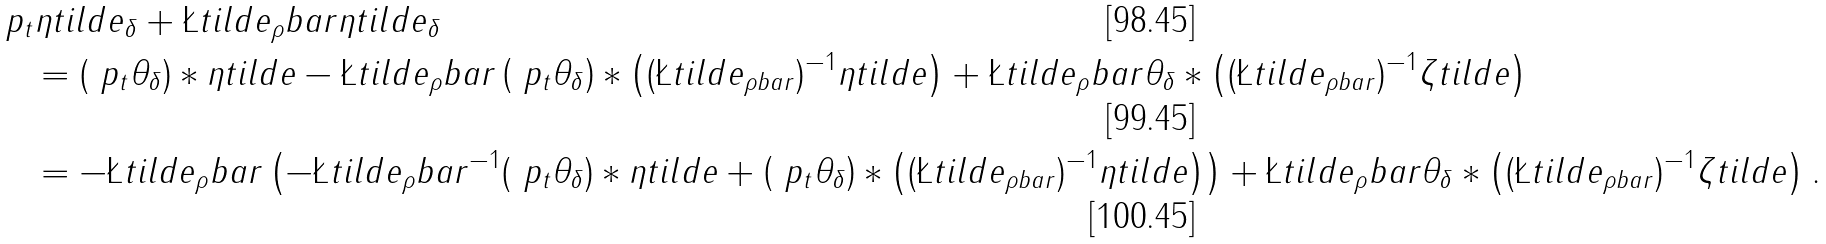Convert formula to latex. <formula><loc_0><loc_0><loc_500><loc_500>& \ p _ { t } \eta t i l d e _ { \delta } + \L t i l d e _ { \rho } b a r \eta t i l d e _ { \delta } \\ & \quad = ( \ p _ { t } \theta _ { \delta } ) * \eta t i l d e - \L t i l d e _ { \rho } b a r \left ( \ p _ { t } \theta _ { \delta } \right ) * \left ( ( \L t i l d e _ { \rho b a r } ) ^ { - 1 } \eta t i l d e \right ) + \L t i l d e _ { \rho } b a r \theta _ { \delta } * \left ( ( \L t i l d e _ { \rho b a r } ) ^ { - 1 } \zeta t i l d e \right ) \\ & \quad = - \L t i l d e _ { \rho } b a r \left ( - \L t i l d e _ { \rho } b a r ^ { - 1 } ( \ p _ { t } \theta _ { \delta } ) * \eta t i l d e + \left ( \ p _ { t } \theta _ { \delta } \right ) * \left ( ( \L t i l d e _ { \rho b a r } ) ^ { - 1 } \eta t i l d e \right ) \right ) + \L t i l d e _ { \rho } b a r \theta _ { \delta } * \left ( ( \L t i l d e _ { \rho b a r } ) ^ { - 1 } \zeta t i l d e \right ) .</formula> 